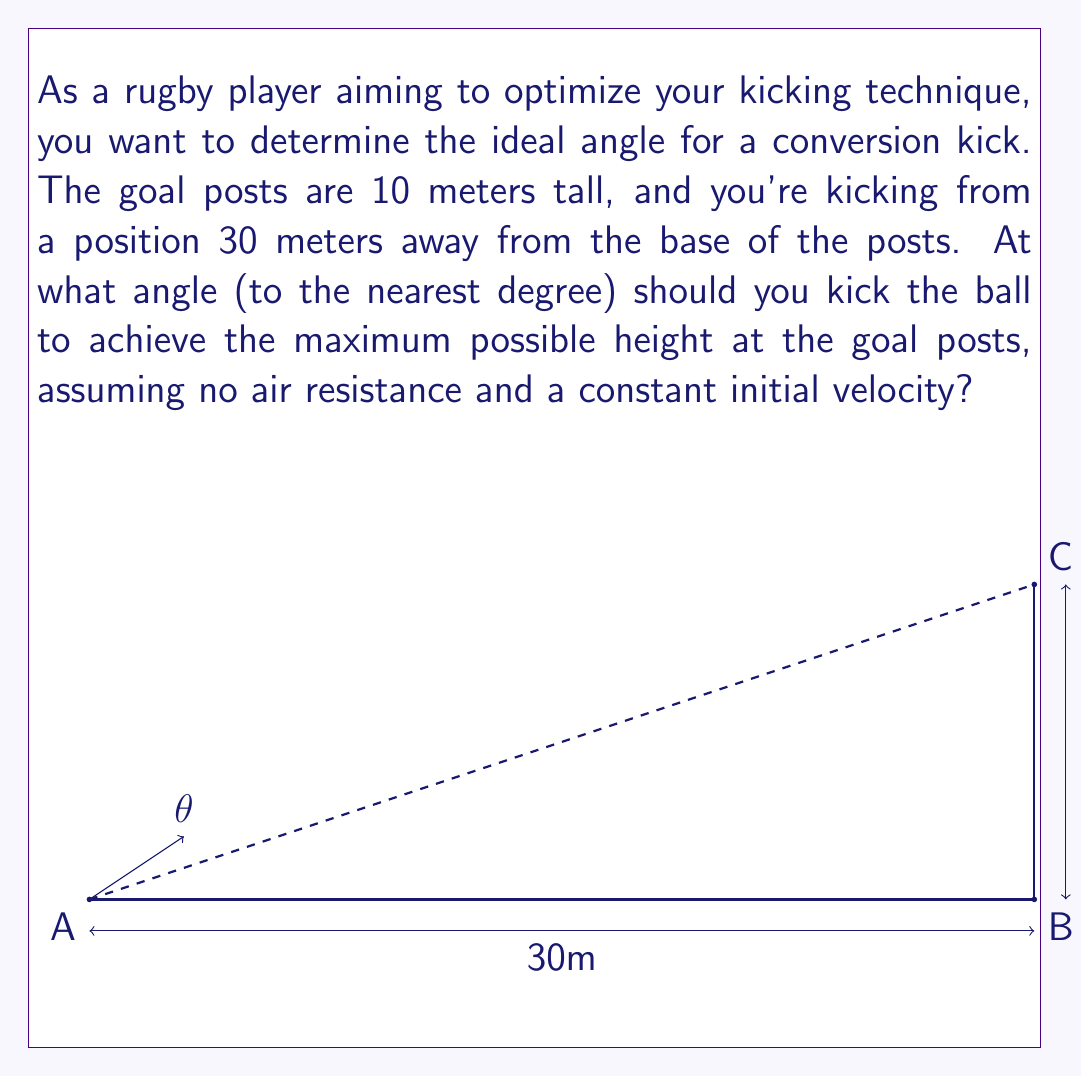Can you answer this question? Let's approach this step-by-step using trigonometry:

1) In this scenario, we want to maximize the height of the ball when it reaches the goal posts. This occurs when the ball's trajectory forms a parabola with its peak exactly at the goal posts.

2) For a projectile motion without air resistance, the maximum range occurs at a 45° angle. However, we're not aiming for maximum range, but maximum height at a specific distance.

3) Let's consider the right triangle formed by the kicker (A), the base of the goal posts (B), and the top of the goal posts (C).

4) We know:
   - The adjacent side (AB) = 30 meters
   - The opposite side (BC) = 10 meters

5) We can find the angle θ using the tangent function:

   $$\tan(\theta) = \frac{\text{opposite}}{\text{adjacent}} = \frac{10}{30} = \frac{1}{3}$$

6) To solve for θ, we use the inverse tangent (arctangent) function:

   $$\theta = \arctan(\frac{1}{3})$$

7) Using a calculator or computer, we can evaluate this:

   $$\theta \approx 18.43^\circ$$

8) Rounding to the nearest degree as requested:

   $$\theta \approx 18^\circ$$

This angle will ensure that the ball reaches its maximum height at the goal posts, optimizing the chance of a successful conversion kick.
Answer: 18° 